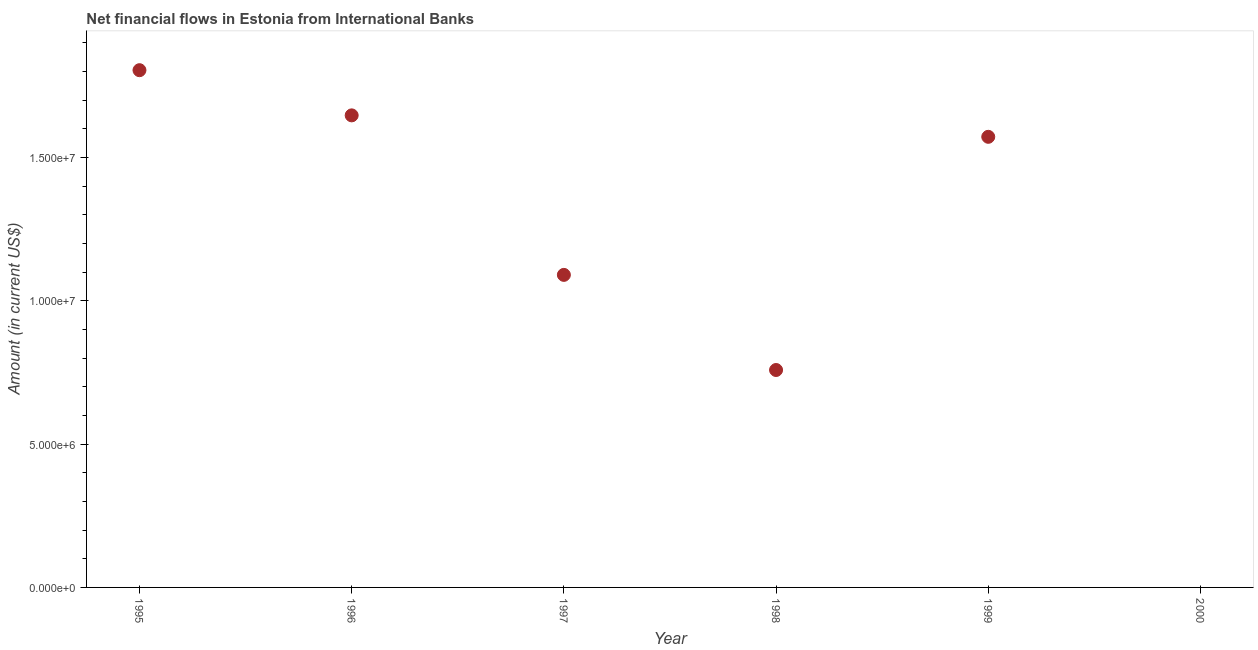What is the net financial flows from ibrd in 1998?
Provide a succinct answer. 7.58e+06. Across all years, what is the maximum net financial flows from ibrd?
Keep it short and to the point. 1.80e+07. In which year was the net financial flows from ibrd maximum?
Provide a short and direct response. 1995. What is the sum of the net financial flows from ibrd?
Your response must be concise. 6.87e+07. What is the difference between the net financial flows from ibrd in 1996 and 1998?
Keep it short and to the point. 8.88e+06. What is the average net financial flows from ibrd per year?
Your response must be concise. 1.15e+07. What is the median net financial flows from ibrd?
Keep it short and to the point. 1.33e+07. In how many years, is the net financial flows from ibrd greater than 3000000 US$?
Make the answer very short. 5. What is the ratio of the net financial flows from ibrd in 1995 to that in 1997?
Your answer should be compact. 1.65. What is the difference between the highest and the second highest net financial flows from ibrd?
Your answer should be very brief. 1.58e+06. Is the sum of the net financial flows from ibrd in 1997 and 1998 greater than the maximum net financial flows from ibrd across all years?
Your response must be concise. Yes. What is the difference between the highest and the lowest net financial flows from ibrd?
Offer a terse response. 1.80e+07. How many dotlines are there?
Your response must be concise. 1. How many years are there in the graph?
Offer a very short reply. 6. Does the graph contain any zero values?
Provide a succinct answer. Yes. Does the graph contain grids?
Offer a terse response. No. What is the title of the graph?
Keep it short and to the point. Net financial flows in Estonia from International Banks. What is the label or title of the Y-axis?
Provide a short and direct response. Amount (in current US$). What is the Amount (in current US$) in 1995?
Offer a terse response. 1.80e+07. What is the Amount (in current US$) in 1996?
Keep it short and to the point. 1.65e+07. What is the Amount (in current US$) in 1997?
Make the answer very short. 1.09e+07. What is the Amount (in current US$) in 1998?
Provide a short and direct response. 7.58e+06. What is the Amount (in current US$) in 1999?
Offer a very short reply. 1.57e+07. What is the difference between the Amount (in current US$) in 1995 and 1996?
Keep it short and to the point. 1.58e+06. What is the difference between the Amount (in current US$) in 1995 and 1997?
Ensure brevity in your answer.  7.14e+06. What is the difference between the Amount (in current US$) in 1995 and 1998?
Give a very brief answer. 1.05e+07. What is the difference between the Amount (in current US$) in 1995 and 1999?
Ensure brevity in your answer.  2.32e+06. What is the difference between the Amount (in current US$) in 1996 and 1997?
Offer a terse response. 5.56e+06. What is the difference between the Amount (in current US$) in 1996 and 1998?
Make the answer very short. 8.88e+06. What is the difference between the Amount (in current US$) in 1996 and 1999?
Your answer should be compact. 7.48e+05. What is the difference between the Amount (in current US$) in 1997 and 1998?
Provide a succinct answer. 3.32e+06. What is the difference between the Amount (in current US$) in 1997 and 1999?
Your response must be concise. -4.82e+06. What is the difference between the Amount (in current US$) in 1998 and 1999?
Ensure brevity in your answer.  -8.13e+06. What is the ratio of the Amount (in current US$) in 1995 to that in 1996?
Provide a succinct answer. 1.1. What is the ratio of the Amount (in current US$) in 1995 to that in 1997?
Provide a short and direct response. 1.66. What is the ratio of the Amount (in current US$) in 1995 to that in 1998?
Provide a short and direct response. 2.38. What is the ratio of the Amount (in current US$) in 1995 to that in 1999?
Offer a terse response. 1.15. What is the ratio of the Amount (in current US$) in 1996 to that in 1997?
Offer a terse response. 1.51. What is the ratio of the Amount (in current US$) in 1996 to that in 1998?
Your answer should be compact. 2.17. What is the ratio of the Amount (in current US$) in 1996 to that in 1999?
Ensure brevity in your answer.  1.05. What is the ratio of the Amount (in current US$) in 1997 to that in 1998?
Provide a succinct answer. 1.44. What is the ratio of the Amount (in current US$) in 1997 to that in 1999?
Ensure brevity in your answer.  0.69. What is the ratio of the Amount (in current US$) in 1998 to that in 1999?
Make the answer very short. 0.48. 